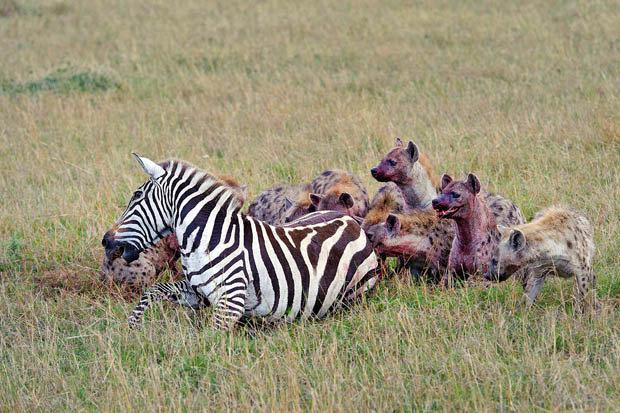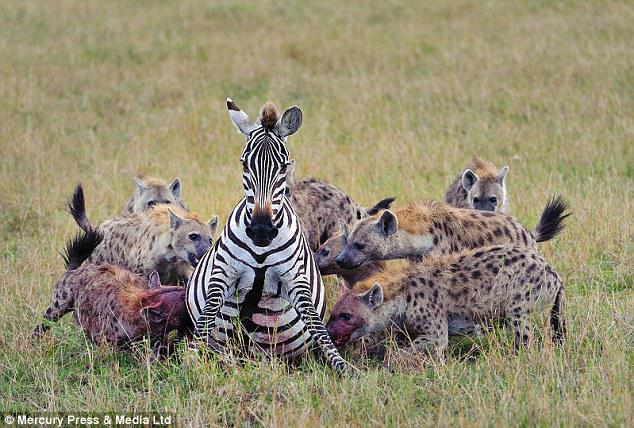The first image is the image on the left, the second image is the image on the right. Analyze the images presented: Is the assertion "An antelope is being attacked in the image on the left." valid? Answer yes or no. No. The first image is the image on the left, the second image is the image on the right. Given the left and right images, does the statement "The right image contains no more than two hyenas." hold true? Answer yes or no. No. 